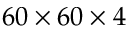Convert formula to latex. <formula><loc_0><loc_0><loc_500><loc_500>6 0 \times 6 0 \times 4</formula> 